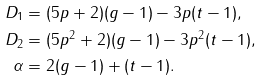Convert formula to latex. <formula><loc_0><loc_0><loc_500><loc_500>D _ { 1 } & = ( 5 p + 2 ) ( g - 1 ) - 3 p ( t - 1 ) , \\ D _ { 2 } & = ( 5 p ^ { 2 } + 2 ) ( g - 1 ) - 3 p ^ { 2 } ( t - 1 ) , \\ \alpha & = 2 ( g - 1 ) + ( t - 1 ) .</formula> 